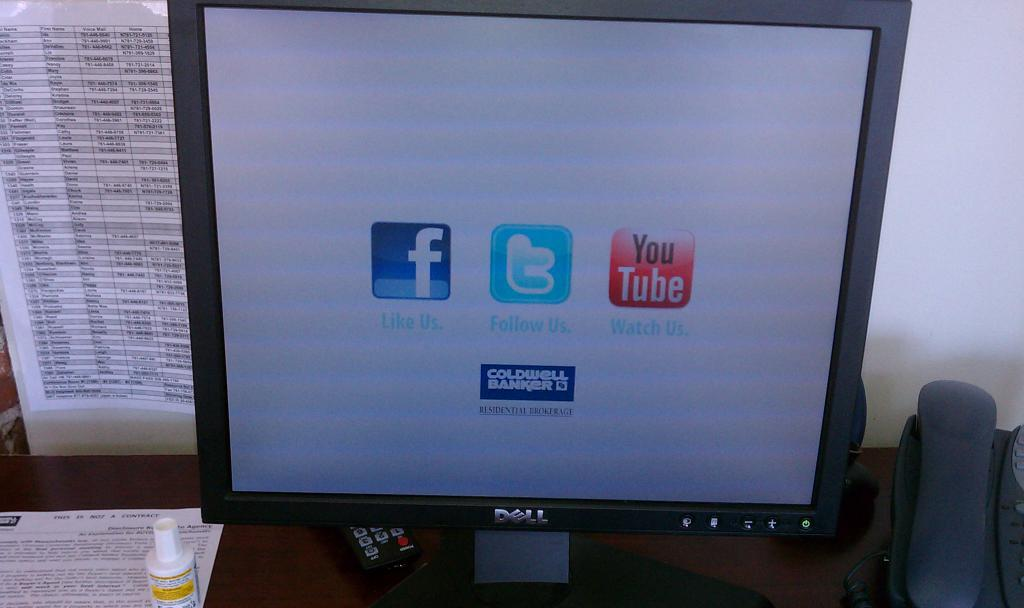<image>
Create a compact narrative representing the image presented. a dell monitor with a home screen sponsored by coldwell bankers 